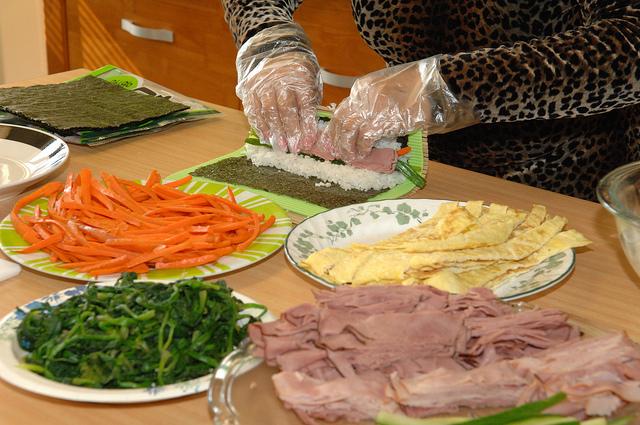What are on the person's hands?
Answer briefly. Gloves. Is this food good for a luncheon?
Be succinct. Yes. What is the person making?
Give a very brief answer. Sushi. 